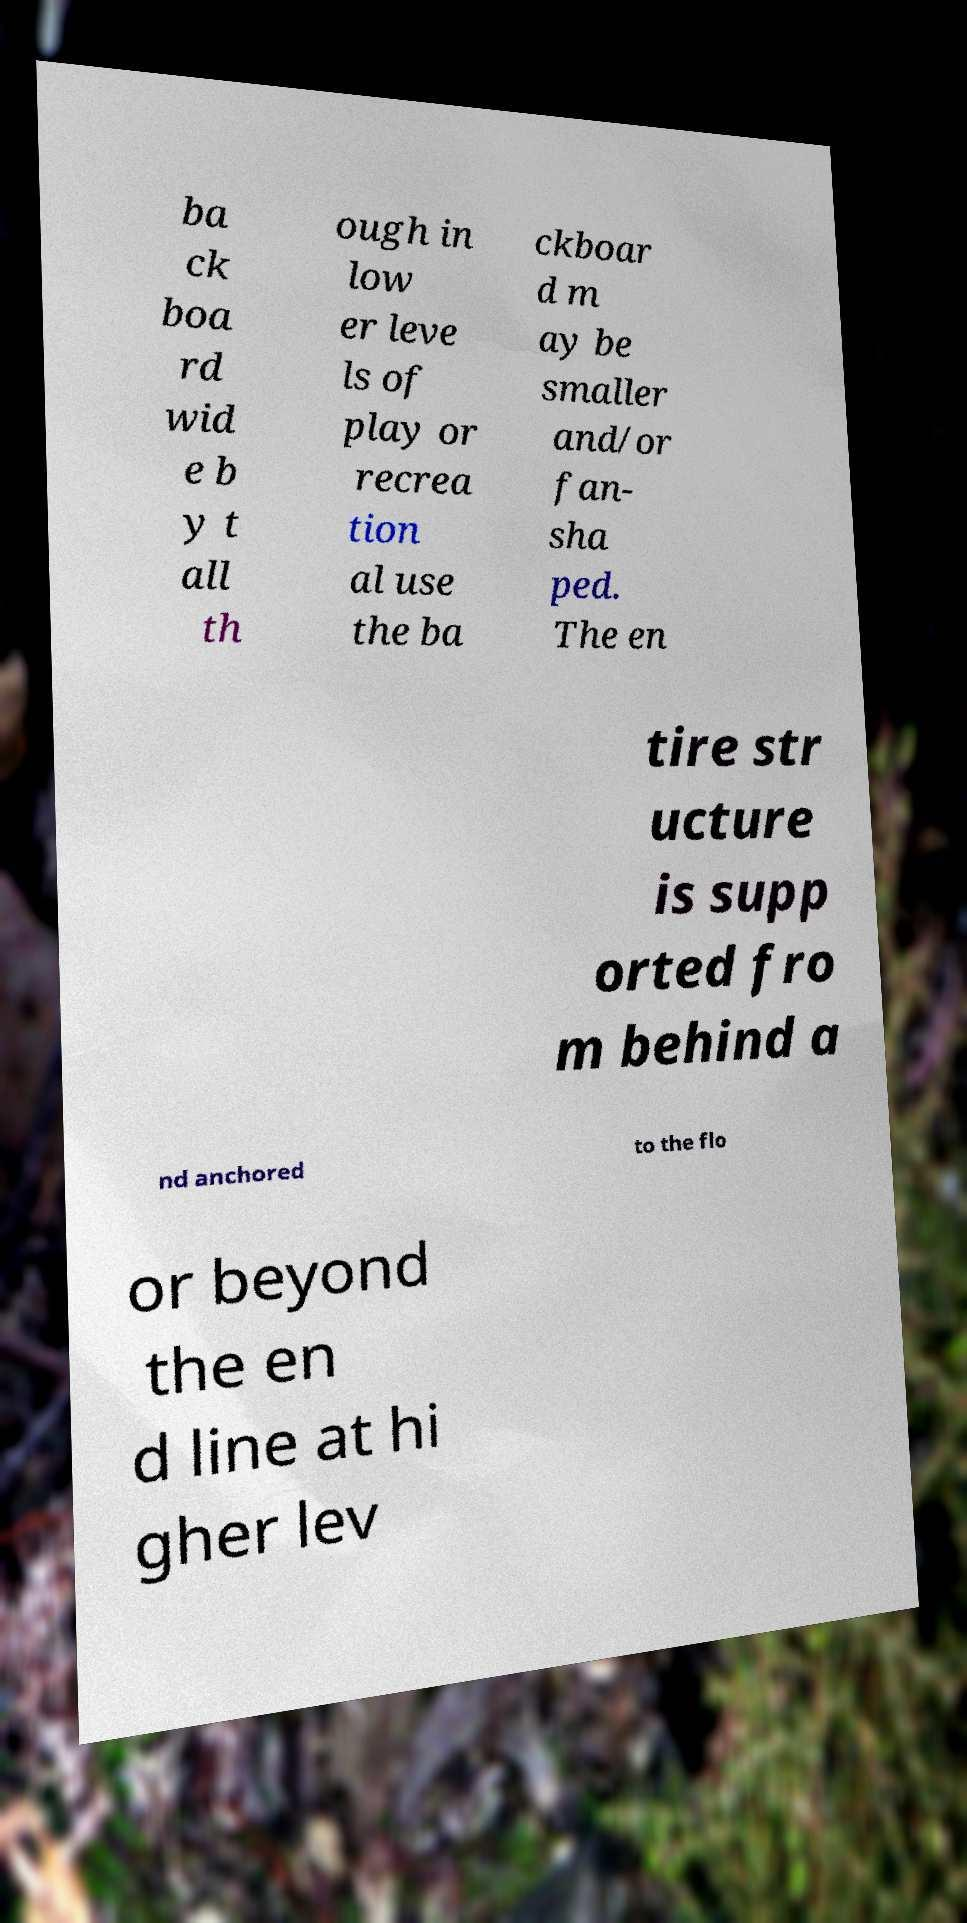Could you extract and type out the text from this image? ba ck boa rd wid e b y t all th ough in low er leve ls of play or recrea tion al use the ba ckboar d m ay be smaller and/or fan- sha ped. The en tire str ucture is supp orted fro m behind a nd anchored to the flo or beyond the en d line at hi gher lev 